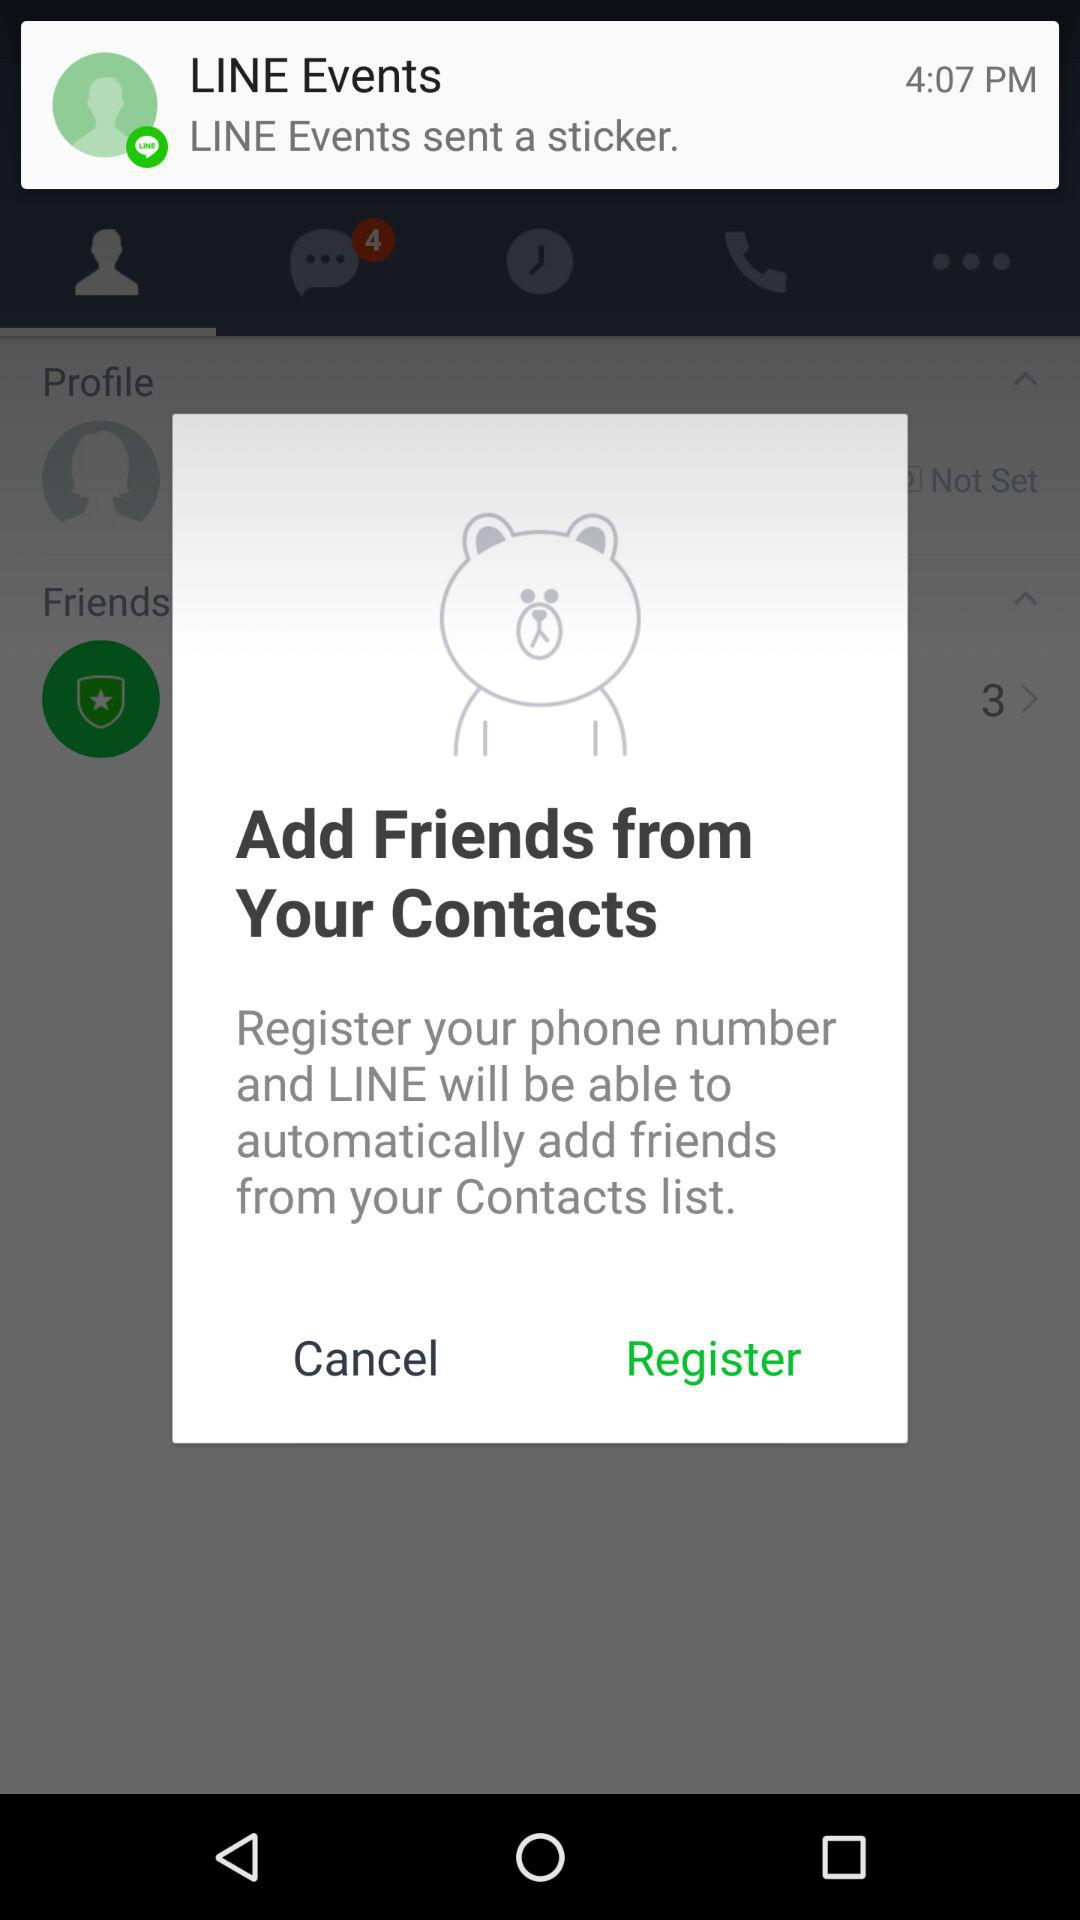What event sent the sticker? The sticker was sent by "LINE Events". 